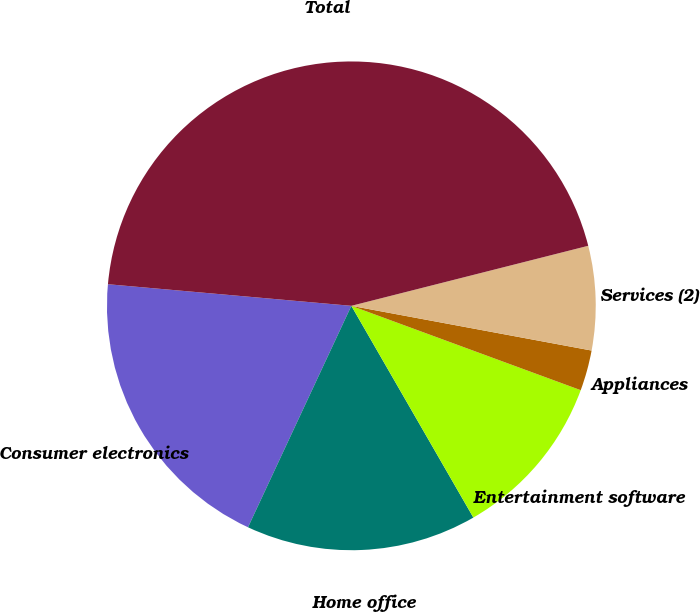Convert chart to OTSL. <chart><loc_0><loc_0><loc_500><loc_500><pie_chart><fcel>Consumer electronics<fcel>Home office<fcel>Entertainment software<fcel>Appliances<fcel>Services (2)<fcel>Total<nl><fcel>19.46%<fcel>15.27%<fcel>11.07%<fcel>2.68%<fcel>6.88%<fcel>44.64%<nl></chart> 